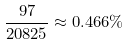Convert formula to latex. <formula><loc_0><loc_0><loc_500><loc_500>\frac { 9 7 } { 2 0 8 2 5 } \approx 0 . 4 6 6 \%</formula> 